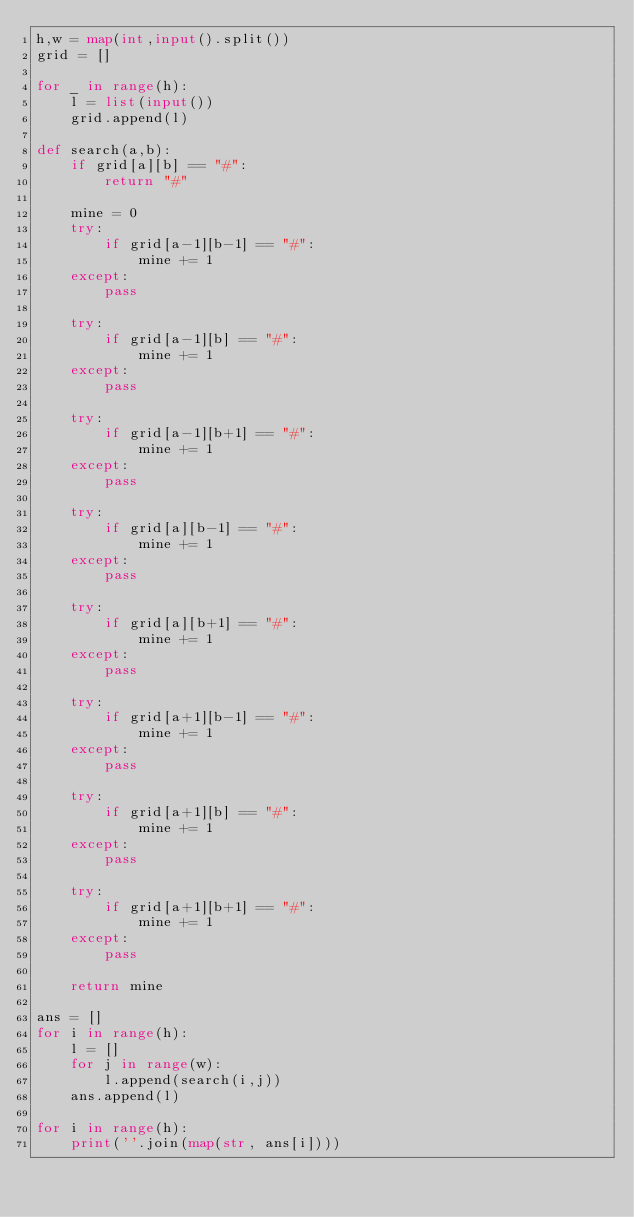Convert code to text. <code><loc_0><loc_0><loc_500><loc_500><_Python_>h,w = map(int,input().split())
grid = []

for _ in range(h):
    l = list(input())
    grid.append(l)

def search(a,b):
    if grid[a][b] == "#":
        return "#"

    mine = 0
    try:
        if grid[a-1][b-1] == "#":
            mine += 1
    except:
        pass

    try:
        if grid[a-1][b] == "#":
            mine += 1
    except:
        pass

    try:
        if grid[a-1][b+1] == "#":
            mine += 1
    except:
        pass

    try:
        if grid[a][b-1] == "#":
            mine += 1
    except:
        pass

    try:
        if grid[a][b+1] == "#":
            mine += 1
    except:
        pass

    try:
        if grid[a+1][b-1] == "#":
            mine += 1
    except:
        pass

    try:
        if grid[a+1][b] == "#":
            mine += 1
    except:
        pass

    try:
        if grid[a+1][b+1] == "#":
            mine += 1
    except:
        pass

    return mine

ans = []
for i in range(h):
    l = []
    for j in range(w):
        l.append(search(i,j))
    ans.append(l)

for i in range(h):
    print(''.join(map(str, ans[i])))
</code> 